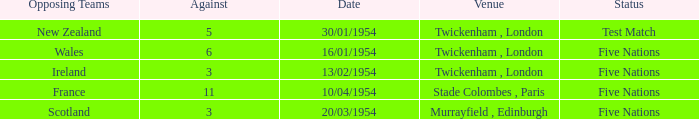Help me parse the entirety of this table. {'header': ['Opposing Teams', 'Against', 'Date', 'Venue', 'Status'], 'rows': [['New Zealand', '5', '30/01/1954', 'Twickenham , London', 'Test Match'], ['Wales', '6', '16/01/1954', 'Twickenham , London', 'Five Nations'], ['Ireland', '3', '13/02/1954', 'Twickenham , London', 'Five Nations'], ['France', '11', '10/04/1954', 'Stade Colombes , Paris', 'Five Nations'], ['Scotland', '3', '20/03/1954', 'Murrayfield , Edinburgh', 'Five Nations']]} What was the venue for the game played on 16/01/1954, when the against was more than 3? Twickenham , London. 